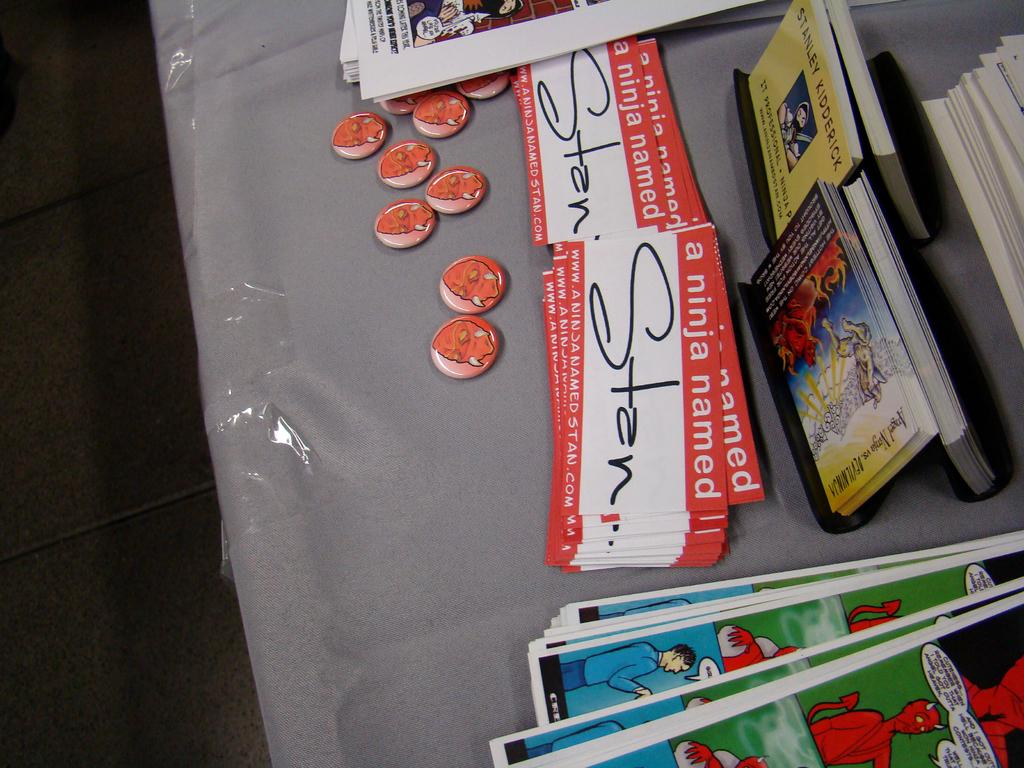Provide a one-sentence caption for the provided image. Promotional materials for a project titled A Ninja Named Stan fill a table. 